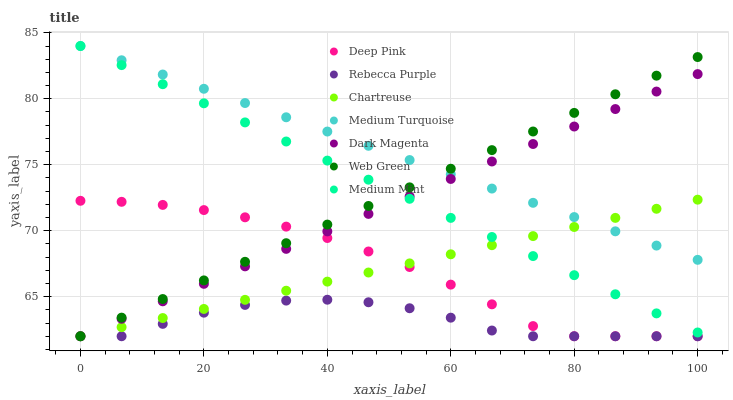Does Rebecca Purple have the minimum area under the curve?
Answer yes or no. Yes. Does Medium Turquoise have the maximum area under the curve?
Answer yes or no. Yes. Does Deep Pink have the minimum area under the curve?
Answer yes or no. No. Does Deep Pink have the maximum area under the curve?
Answer yes or no. No. Is Medium Mint the smoothest?
Answer yes or no. Yes. Is Rebecca Purple the roughest?
Answer yes or no. Yes. Is Deep Pink the smoothest?
Answer yes or no. No. Is Deep Pink the roughest?
Answer yes or no. No. Does Deep Pink have the lowest value?
Answer yes or no. Yes. Does Medium Turquoise have the lowest value?
Answer yes or no. No. Does Medium Turquoise have the highest value?
Answer yes or no. Yes. Does Deep Pink have the highest value?
Answer yes or no. No. Is Deep Pink less than Medium Turquoise?
Answer yes or no. Yes. Is Medium Mint greater than Deep Pink?
Answer yes or no. Yes. Does Chartreuse intersect Web Green?
Answer yes or no. Yes. Is Chartreuse less than Web Green?
Answer yes or no. No. Is Chartreuse greater than Web Green?
Answer yes or no. No. Does Deep Pink intersect Medium Turquoise?
Answer yes or no. No. 